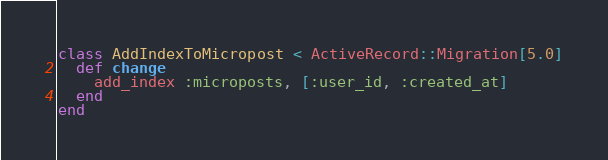Convert code to text. <code><loc_0><loc_0><loc_500><loc_500><_Ruby_>class AddIndexToMicropost < ActiveRecord::Migration[5.0]
  def change
  	add_index :microposts, [:user_id, :created_at]
  end
end
</code> 